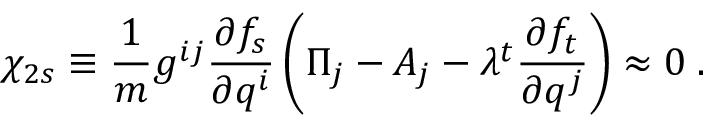<formula> <loc_0><loc_0><loc_500><loc_500>\chi _ { 2 s } \equiv \frac { 1 } { m } g ^ { i j } \frac { \partial f _ { s } } { \partial q ^ { i } } \left ( \Pi _ { j } - A _ { j } - \lambda ^ { t } \frac { \partial f _ { t } } { \partial q ^ { j } } \right ) \approx 0 \, .</formula> 